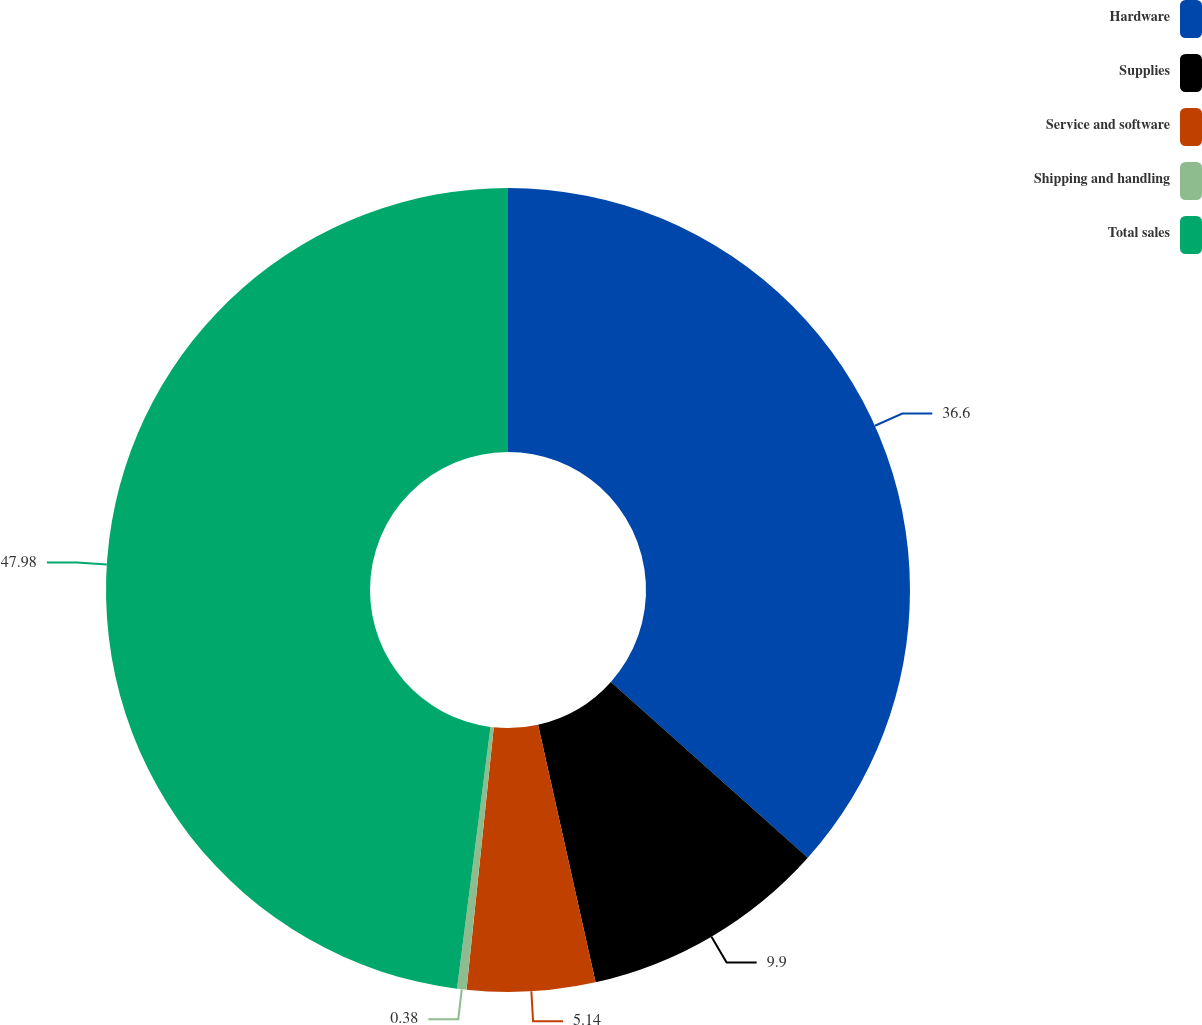Convert chart. <chart><loc_0><loc_0><loc_500><loc_500><pie_chart><fcel>Hardware<fcel>Supplies<fcel>Service and software<fcel>Shipping and handling<fcel>Total sales<nl><fcel>36.6%<fcel>9.9%<fcel>5.14%<fcel>0.38%<fcel>47.97%<nl></chart> 